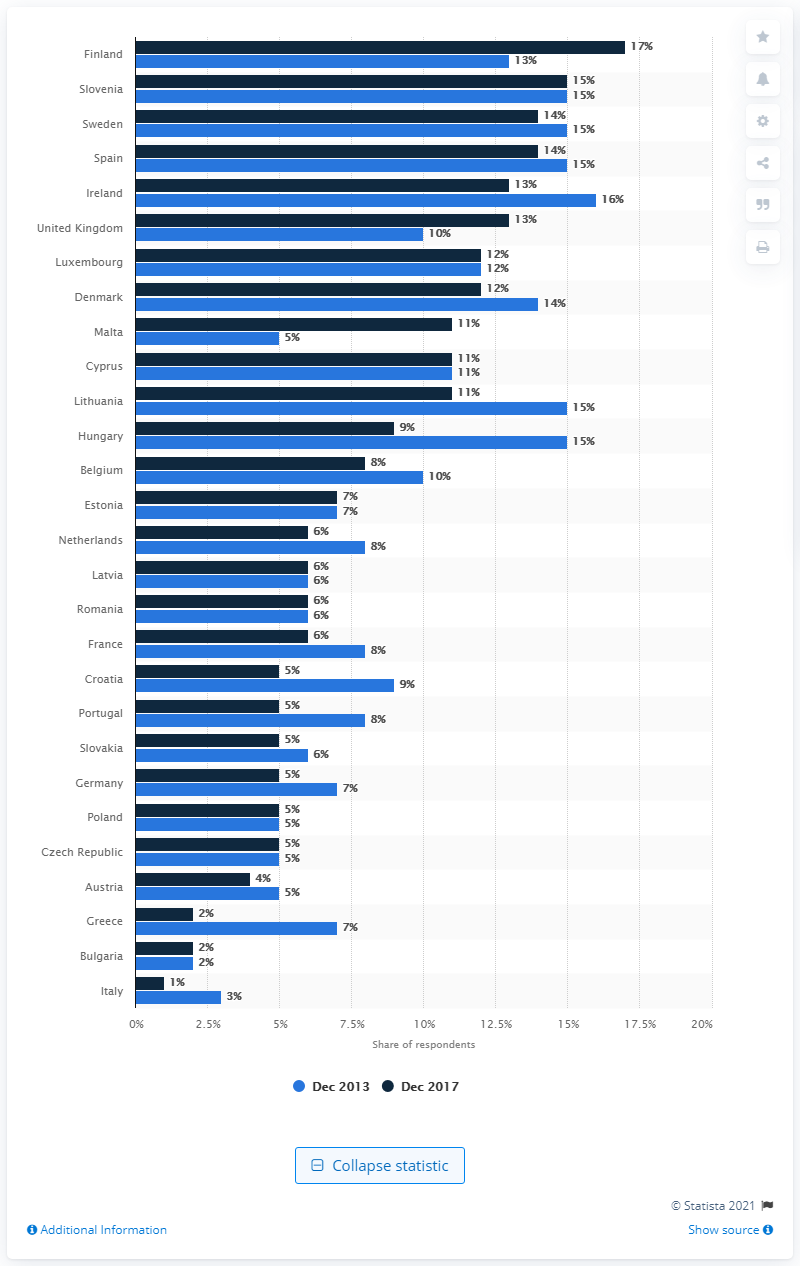Give some essential details in this illustration. Malta has seen a significant increase in the share of people who exercise or play sport at least five times per week, making it a country where physical activity is highly valued and prioritized. 